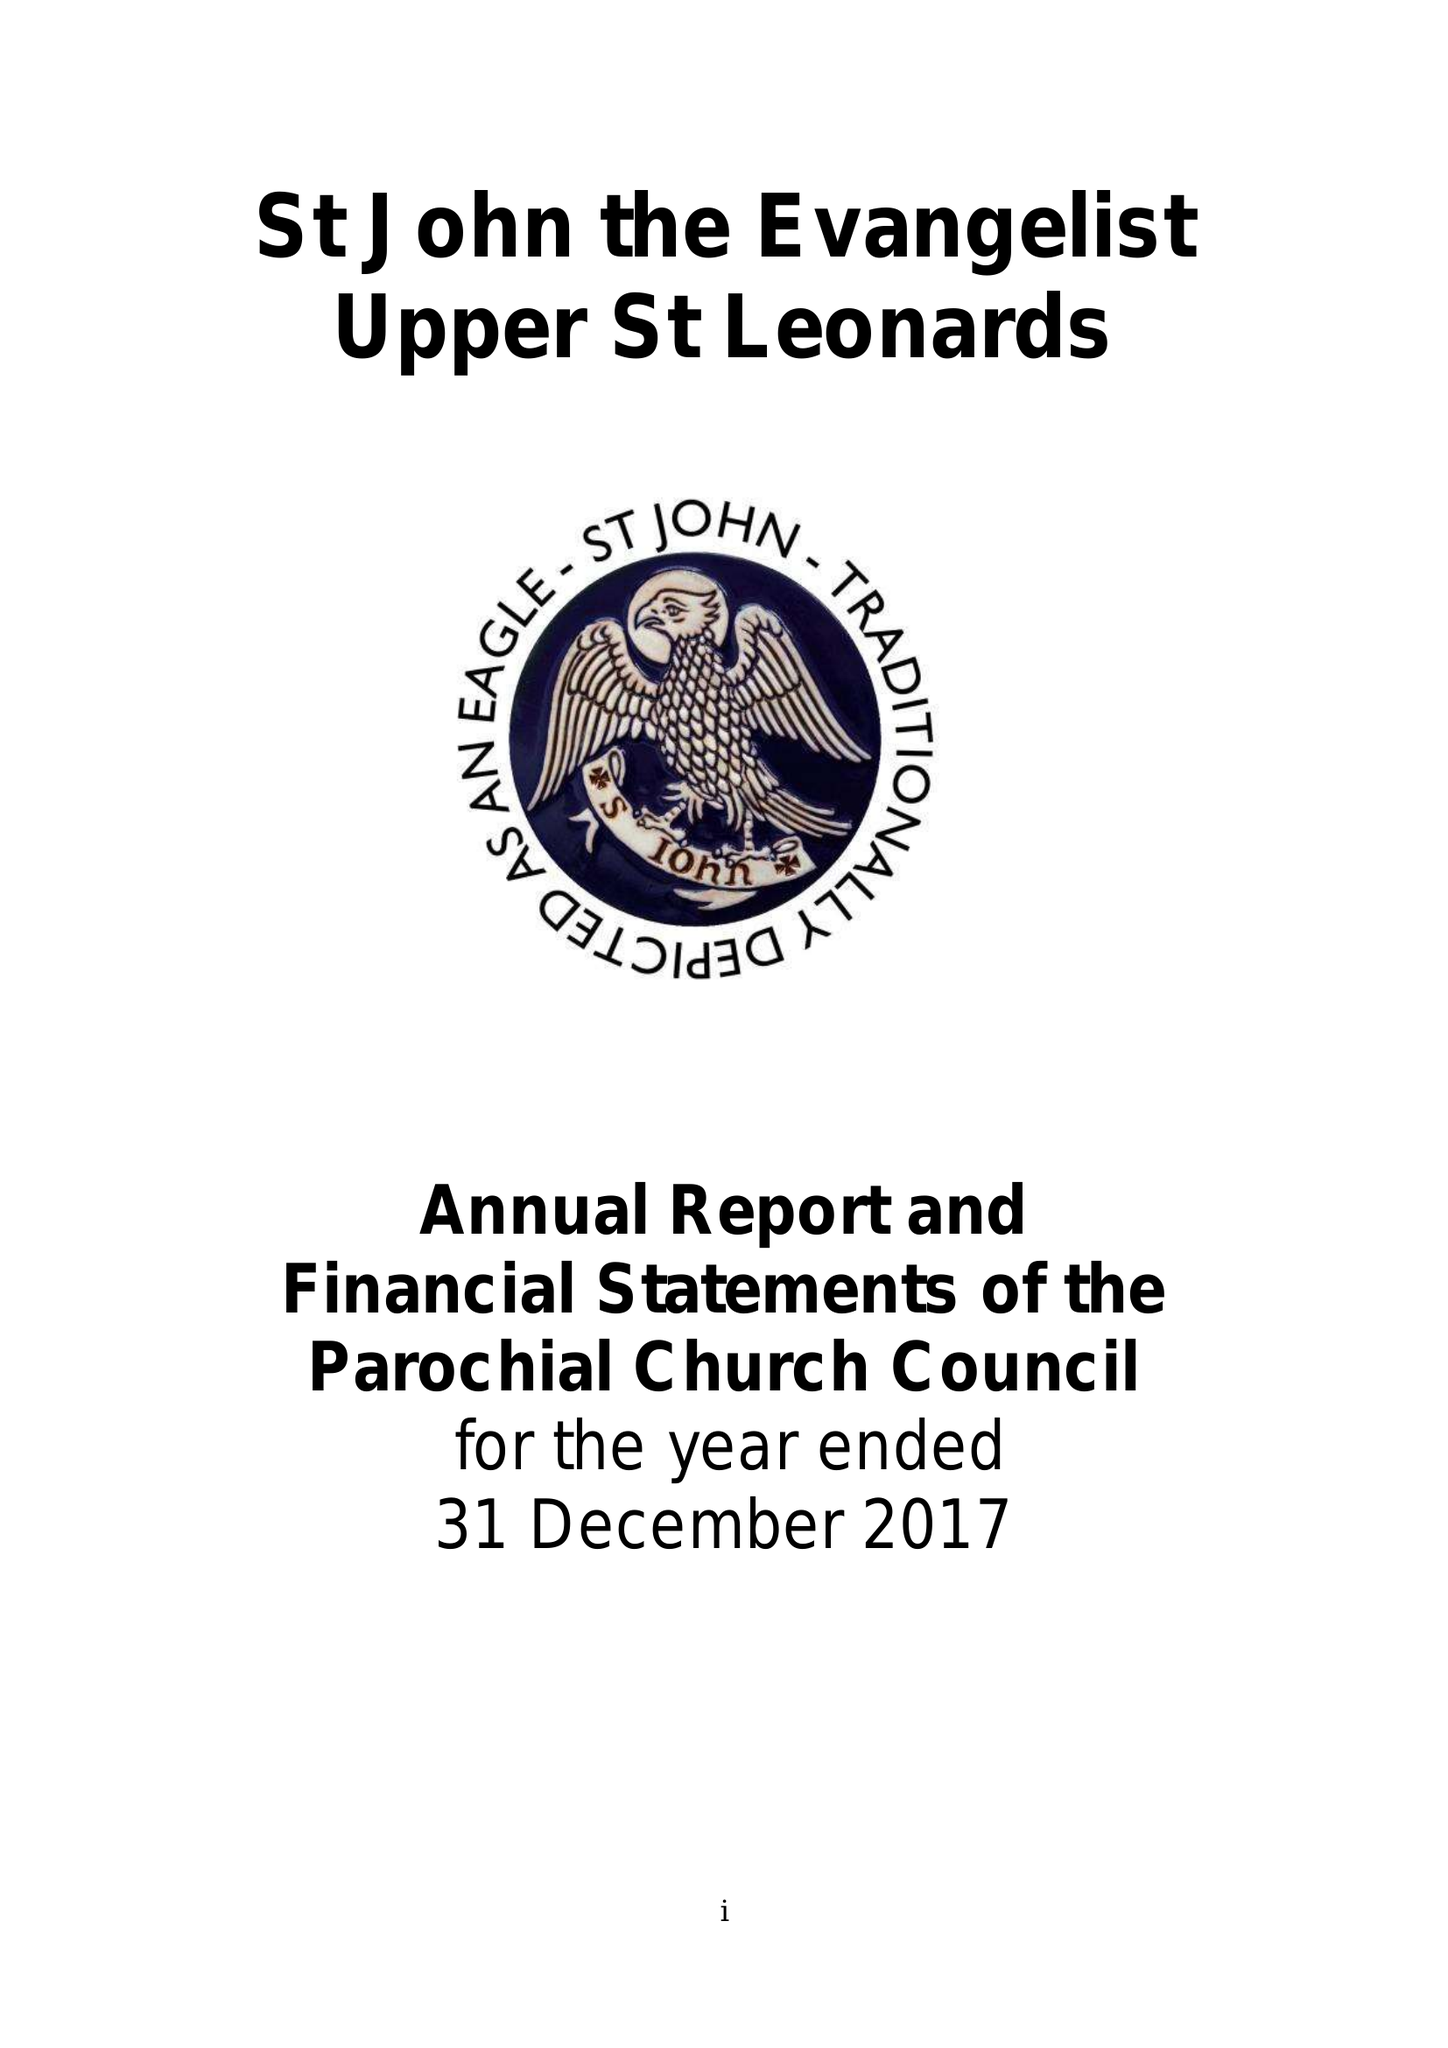What is the value for the spending_annually_in_british_pounds?
Answer the question using a single word or phrase. 127853.00 